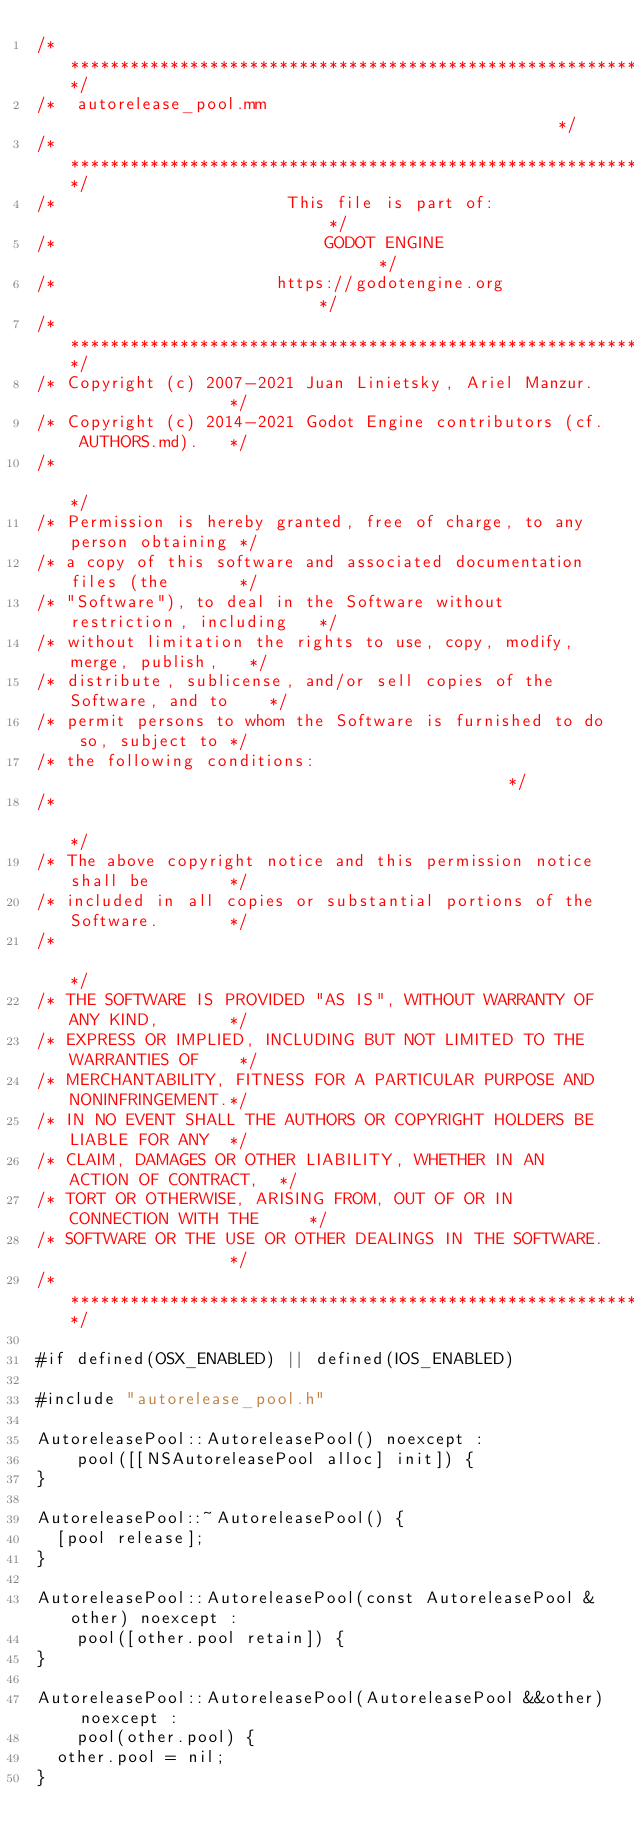Convert code to text. <code><loc_0><loc_0><loc_500><loc_500><_ObjectiveC_>/*************************************************************************/
/*  autorelease_pool.mm                                                  */
/*************************************************************************/
/*                       This file is part of:                           */
/*                           GODOT ENGINE                                */
/*                      https://godotengine.org                          */
/*************************************************************************/
/* Copyright (c) 2007-2021 Juan Linietsky, Ariel Manzur.                 */
/* Copyright (c) 2014-2021 Godot Engine contributors (cf. AUTHORS.md).   */
/*                                                                       */
/* Permission is hereby granted, free of charge, to any person obtaining */
/* a copy of this software and associated documentation files (the       */
/* "Software"), to deal in the Software without restriction, including   */
/* without limitation the rights to use, copy, modify, merge, publish,   */
/* distribute, sublicense, and/or sell copies of the Software, and to    */
/* permit persons to whom the Software is furnished to do so, subject to */
/* the following conditions:                                             */
/*                                                                       */
/* The above copyright notice and this permission notice shall be        */
/* included in all copies or substantial portions of the Software.       */
/*                                                                       */
/* THE SOFTWARE IS PROVIDED "AS IS", WITHOUT WARRANTY OF ANY KIND,       */
/* EXPRESS OR IMPLIED, INCLUDING BUT NOT LIMITED TO THE WARRANTIES OF    */
/* MERCHANTABILITY, FITNESS FOR A PARTICULAR PURPOSE AND NONINFRINGEMENT.*/
/* IN NO EVENT SHALL THE AUTHORS OR COPYRIGHT HOLDERS BE LIABLE FOR ANY  */
/* CLAIM, DAMAGES OR OTHER LIABILITY, WHETHER IN AN ACTION OF CONTRACT,  */
/* TORT OR OTHERWISE, ARISING FROM, OUT OF OR IN CONNECTION WITH THE     */
/* SOFTWARE OR THE USE OR OTHER DEALINGS IN THE SOFTWARE.                */
/*************************************************************************/

#if defined(OSX_ENABLED) || defined(IOS_ENABLED)

#include "autorelease_pool.h"

AutoreleasePool::AutoreleasePool() noexcept :
		pool([[NSAutoreleasePool alloc] init]) {
}

AutoreleasePool::~AutoreleasePool() {
	[pool release];
}

AutoreleasePool::AutoreleasePool(const AutoreleasePool &other) noexcept :
		pool([other.pool retain]) {
}

AutoreleasePool::AutoreleasePool(AutoreleasePool &&other) noexcept :
		pool(other.pool) {
	other.pool = nil;
}
</code> 